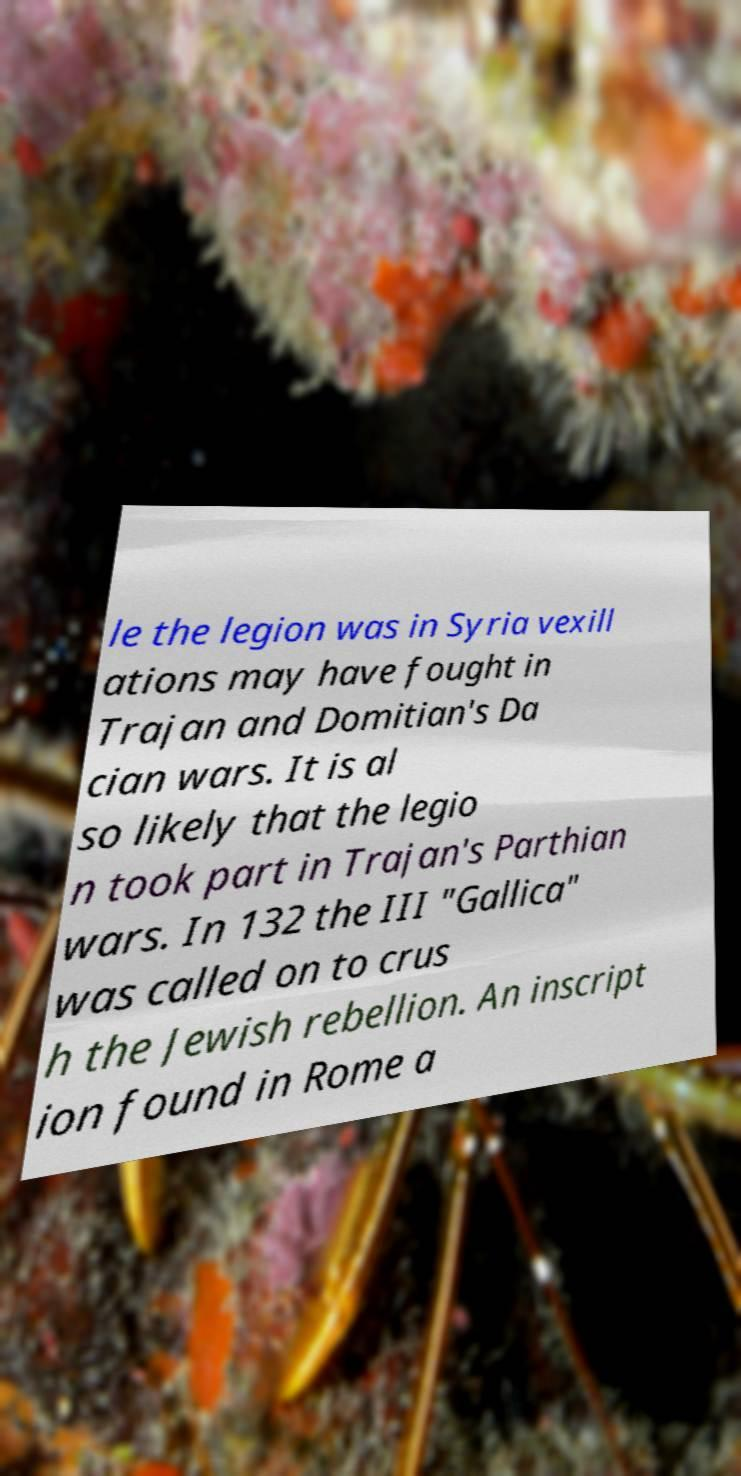Please identify and transcribe the text found in this image. le the legion was in Syria vexill ations may have fought in Trajan and Domitian's Da cian wars. It is al so likely that the legio n took part in Trajan's Parthian wars. In 132 the III "Gallica" was called on to crus h the Jewish rebellion. An inscript ion found in Rome a 